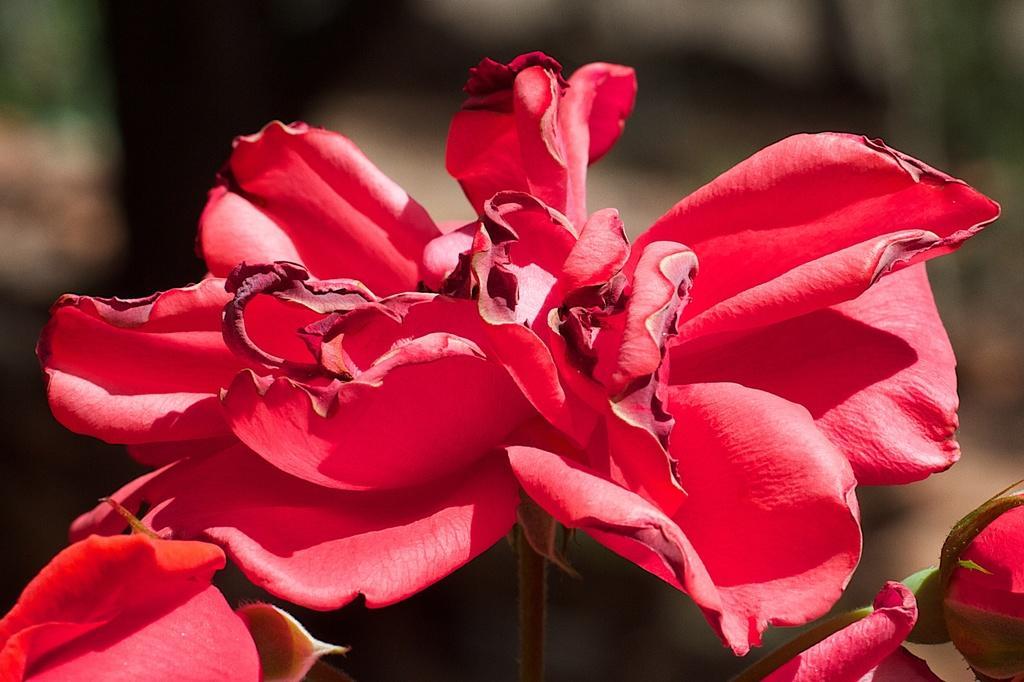Can you describe this image briefly? In this image we can see the red color flowers and the background is blurred. 